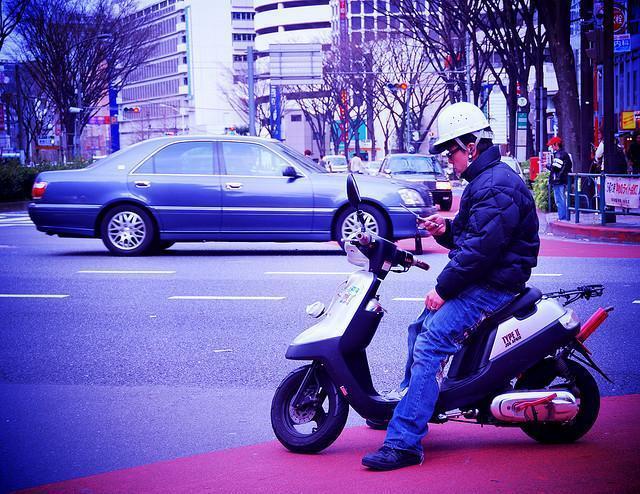How many cars can you see?
Give a very brief answer. 2. 